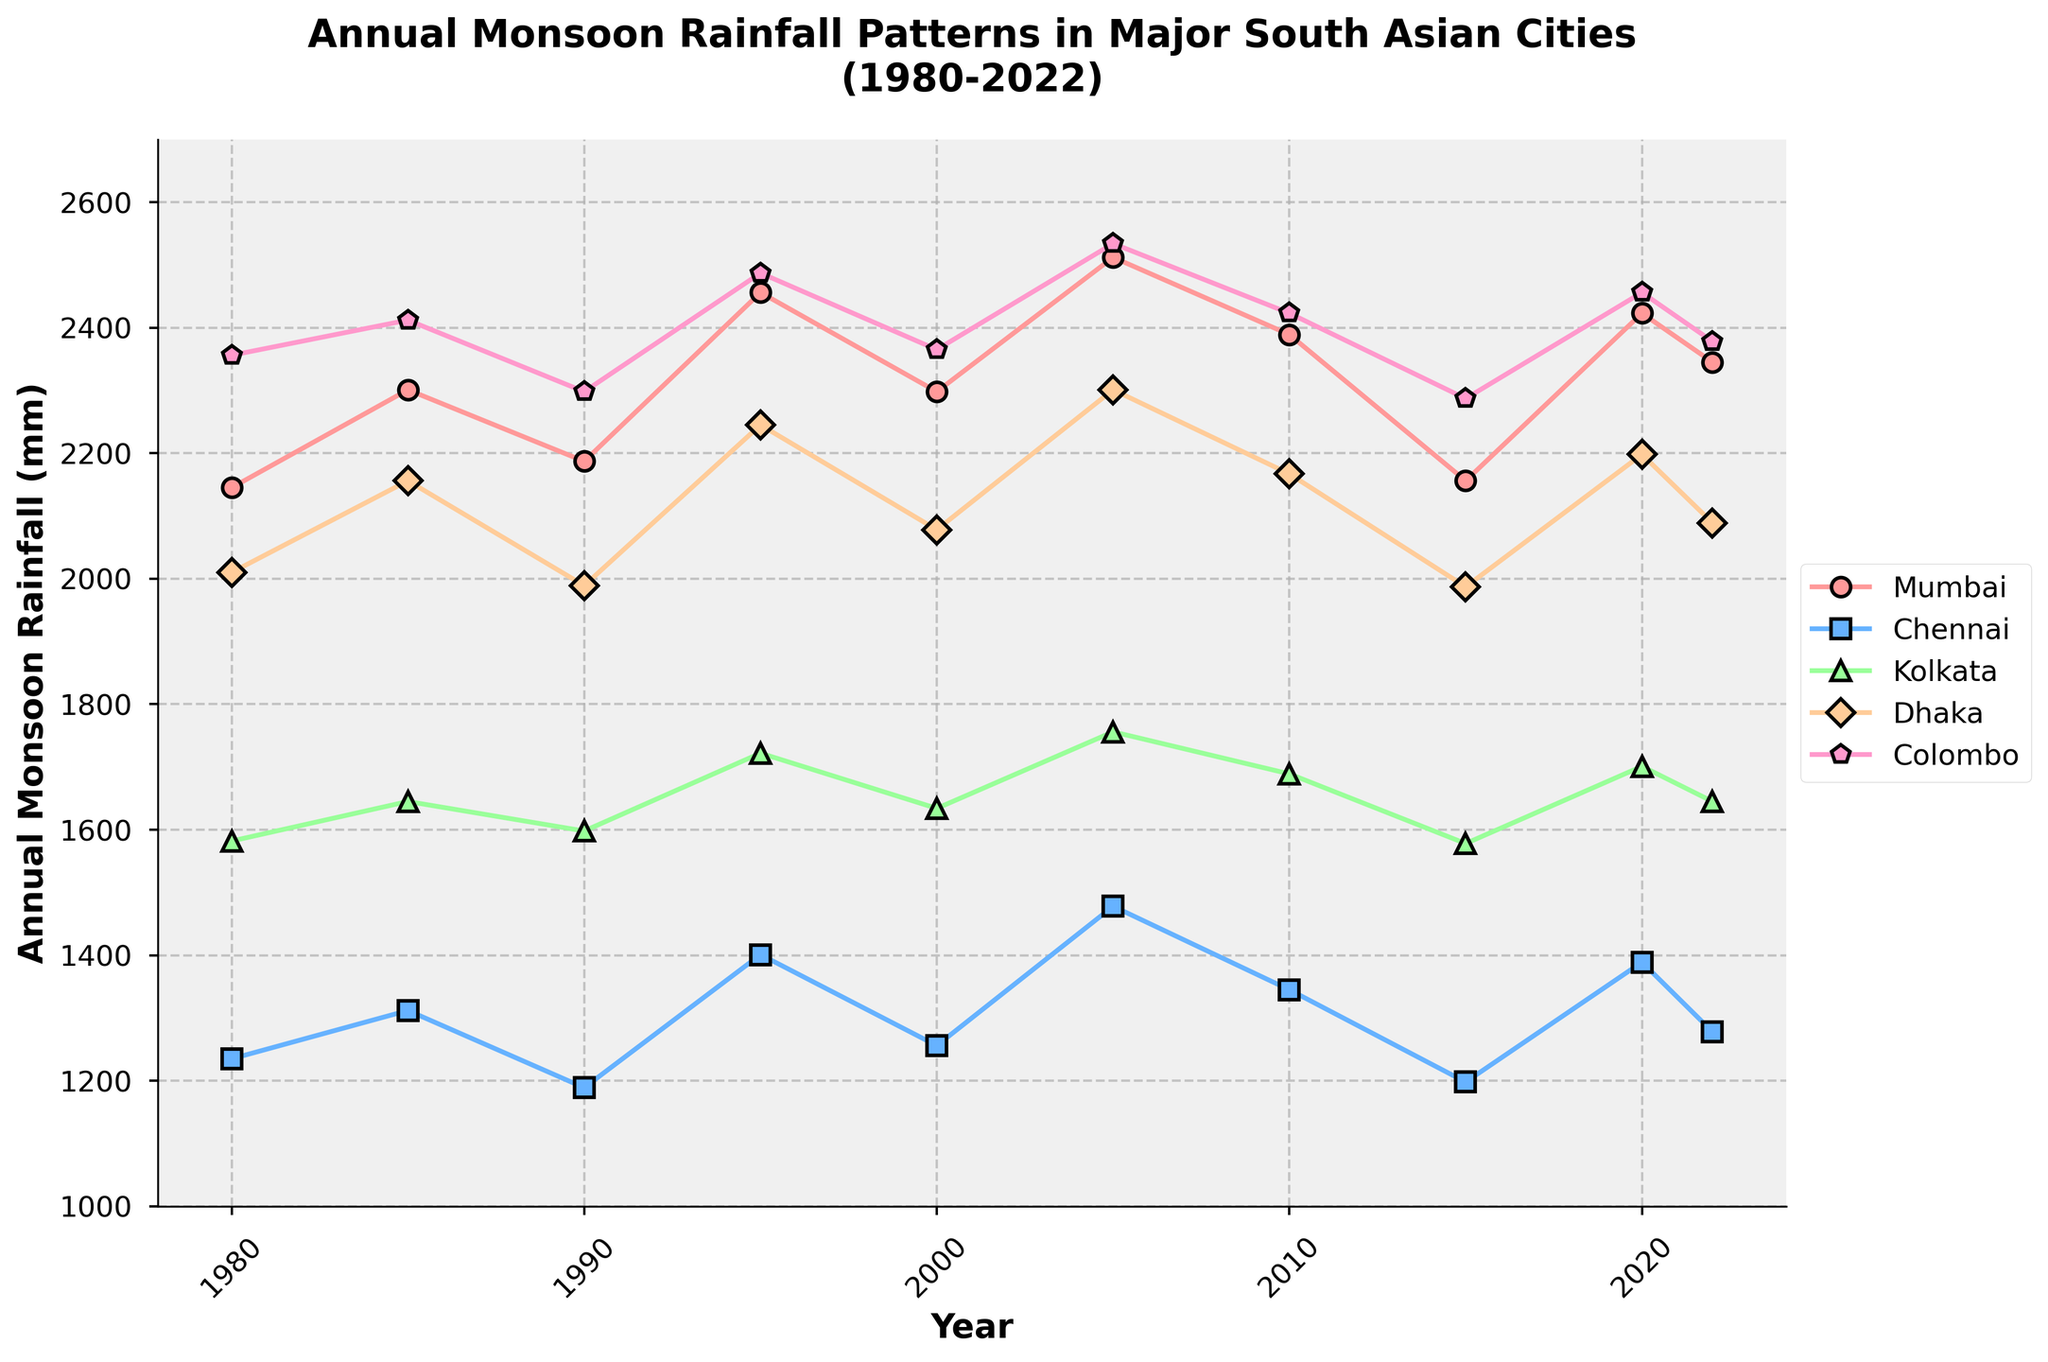What city had the highest annual monsoon rainfall in 2005? To determine which city had the highest annual monsoon rainfall, look at the 2005 values and compare: Mumbai (2512 mm), Chennai (1478 mm), Kolkata (1756 mm), Dhaka (2301 mm), Colombo (2534 mm). Colombo has the highest value.
Answer: Colombo Between 1985 and 1990, did annual monsoon rainfall in Chennai increase or decrease? Look at the values for Chennai in 1985 (1312 mm) and in 1990 (1189 mm). Since 1189 is less than 1312, the rainfall decreased.
Answer: Decrease Which city showed the most consistent rainfall patterns from 1980 to 2020? Look at the fluctuations in the line graphs of each city. Mumbai, Chennai, Kolkata, Dhaka, and Colombo all show variability, but Chennai has relatively moderate changes compared to others.
Answer: Chennai What is the range of the annual monsoon rainfall in Kolkata over the years? Calculate the difference between the maximum and minimum rainfall values for Kolkata. The max value is 1756 mm (2005), and the min is 1578 mm (2015). The range is 1756 - 1578 = 178 mm.
Answer: 178 mm In which year did Dhaka have the lowest annual monsoon rainfall? Look at Dhaka's rainfall values from 1980 to 2022. The lowest value is 1987 mm in 2015.
Answer: 2015 Compare the rainfall patterns of Mumbai and Dhaka. Did they ever cross, and if so, when? To determine if they crossed, look for any intersection in the graphed lines. Both lines cross between 1990 and 1995, close to 1995.
Answer: Around 1995 What is the average annual monsoon rainfall in Colombo over the provided years? Sum the rainfall values for Colombo: 2356 + 2412 + 2298 + 2487 + 2365 + 2534 + 2423 + 2287 + 2456 + 2378 = 23996 mm. Divide by the number of years: 23996 / 10 = 2399.6 mm.
Answer: 2399.6 mm Which city had the smallest increase in rainfall from 1980 to 2022? Calculate the difference in rainfall from 1980 to 2022 for each city: Mumbai (2345 - 2145 = 200 mm), Chennai (1278 - 1235 = 43 mm), Kolkata (1645 - 1582 = 63 mm), Dhaka (2089 - 2010 = 79 mm), Colombo (2378 - 2356 = 22 mm). The smallest increase is in Colombo.
Answer: Colombo 